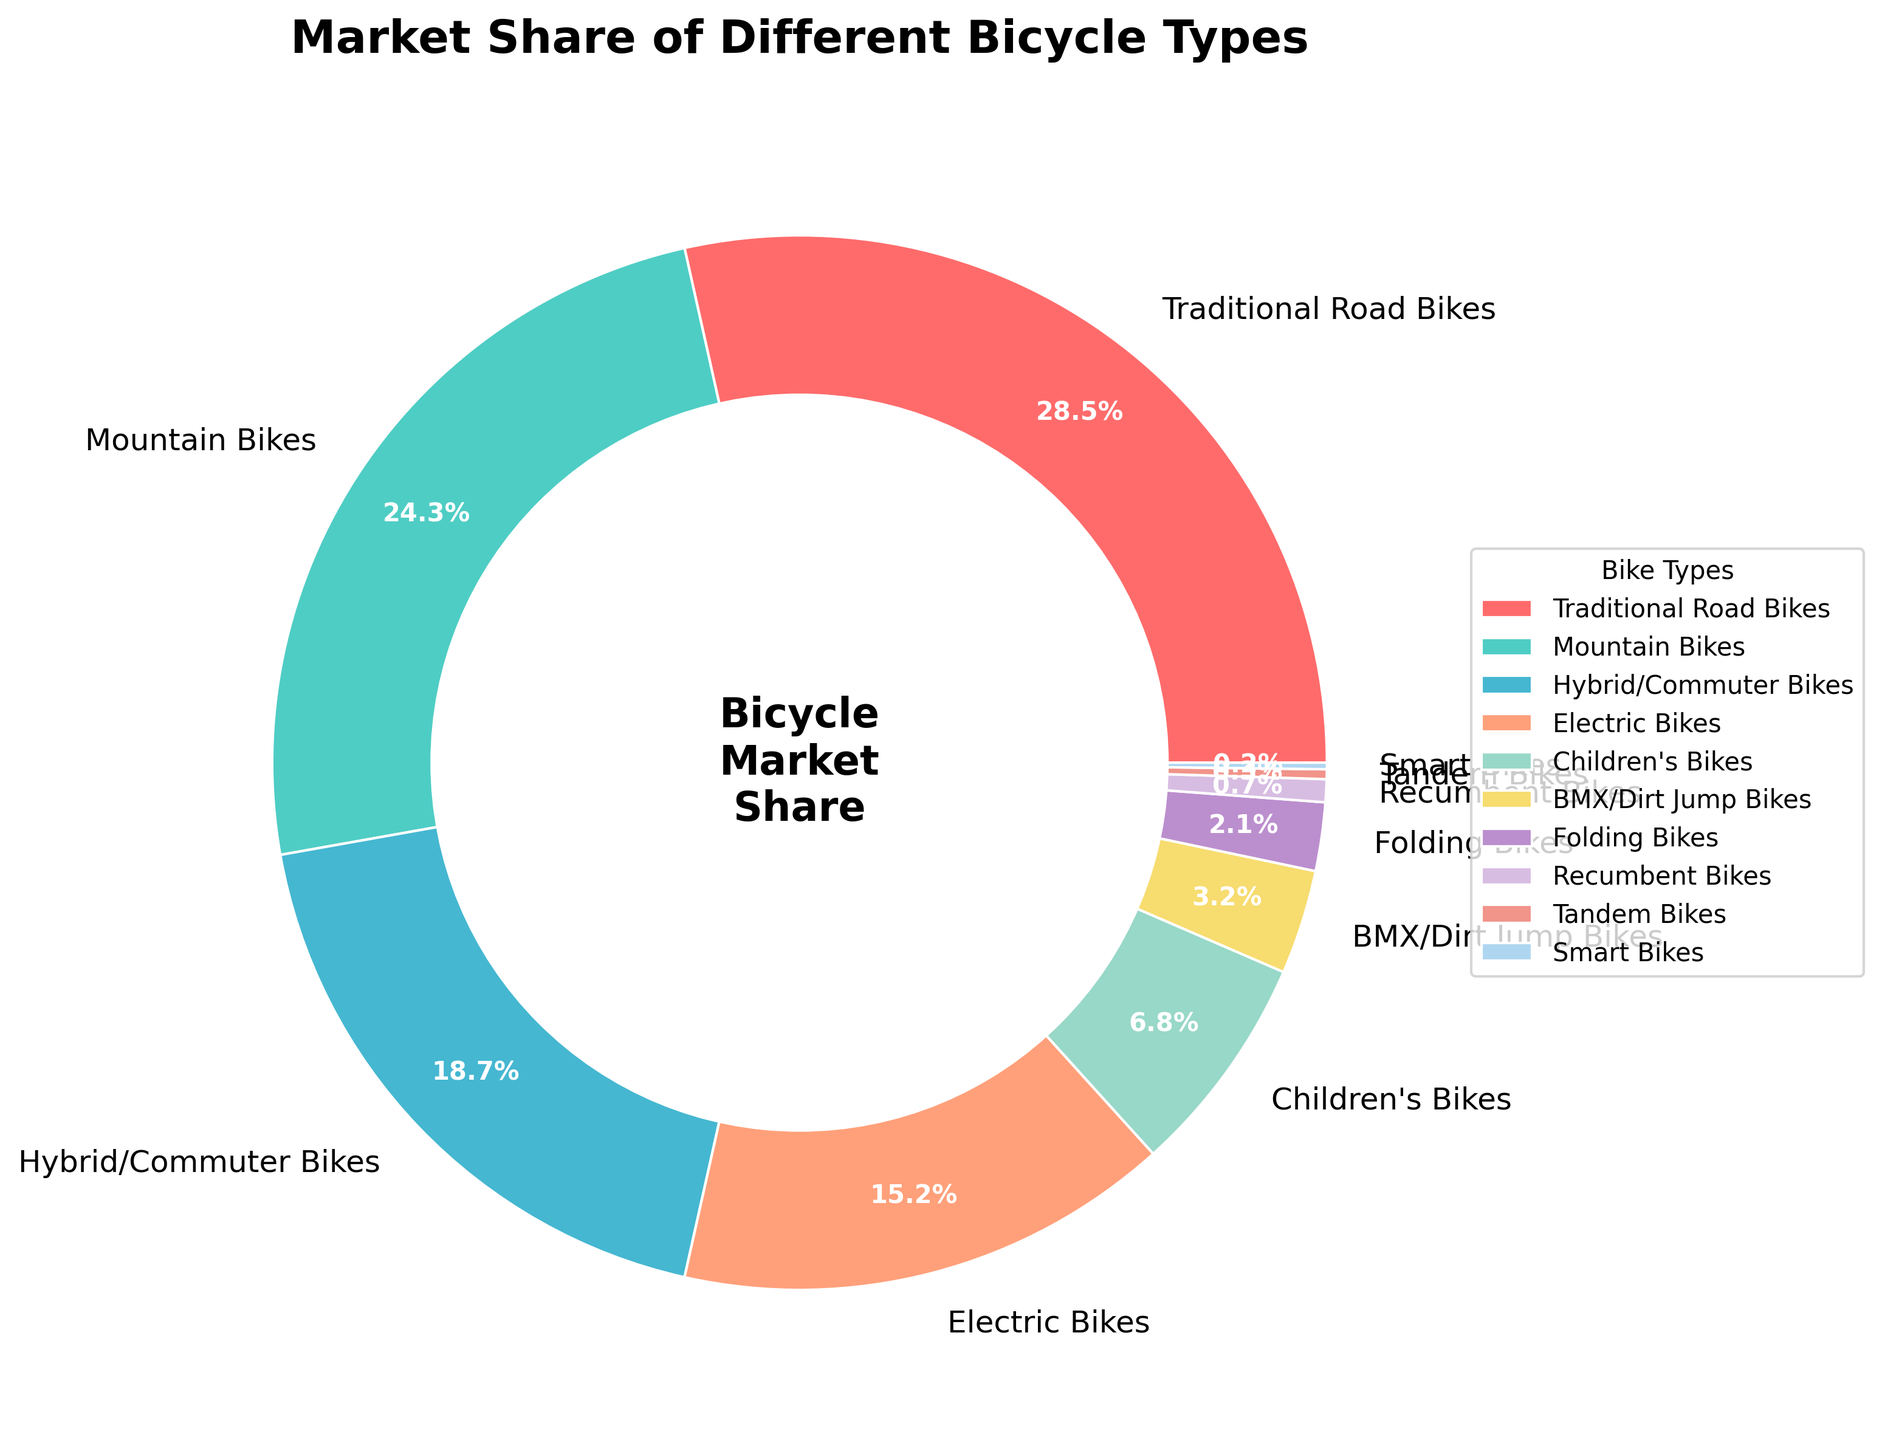What are the two most popular types of bikes and their combined market share? By looking at the wedges of the pie chart, the two largest segments are Traditional Road Bikes (28.5%) and Mountain Bikes (24.3%). Adding these percentages together gives 28.5 + 24.3 = 52.8%.
Answer: Traditional Road Bikes and Mountain Bikes, 52.8% Which bike type has a market share closest to 20%? We need to identify the segment whose percentage is nearest to 20%. Hybrid/Commuter Bikes have a market share of 18.7%, which is the closest to 20%.
Answer: Hybrid/Commuter Bikes Is the market share of Electric Bikes greater than the combined market share of Children's Bikes and BMX/Dirt Jump Bikes? Electric Bikes have a market share of 15.2%. Combined market share of Children's Bikes (6.8%) and BMX/Dirt Jump Bikes (3.2%) is 6.8 + 3.2 = 10%. Since 15.2% > 10%, Electric Bikes' market share is indeed greater.
Answer: Yes What is the total market share of the least popular three bike types? The least popular three types are Smart Bikes (0.2%), Tandem Bikes (0.3%), and Recumbent Bikes (0.7%). Adding their market shares gives 0.2 + 0.3 + 0.7 = 1.2%.
Answer: 1.2% How does the market share of Folding Bikes compare to that of Children's Bikes? By comparing the two wedges, Folding Bikes have a market share of 2.1%, while Children's Bikes have a 6.8% share. Thus, the market share of Folding Bikes is less than that of Children's Bikes.
Answer: Less Which segment is represented by the red color in the pie chart? By referring to the description of colors used, the red color is assigned to the Traditional Road Bikes, which has the largest segment on the pie chart.
Answer: Traditional Road Bikes If you combine the market shares of Hybrid/Commuter Bikes and Electric Bikes, do they surpass the market share of Mountain Bikes? Hybrid/Commuter Bikes have 18.7% and Electric Bikes have 15.2%. Their combined market share is 18.7 + 15.2 = 33.9%. The market share of Mountain Bikes is 24.3%, so 33.9% > 24.3%.
Answer: Yes Which bike type has the smallest market share, and what is its value? By examining the smallest wedge, Smart Bikes have the smallest market share at 0.2%.
Answer: Smart Bikes, 0.2% Is the market share of Traditional Road Bikes more than double that of Hybrid/Commuter Bikes? Traditional Road Bikes have a share of 28.5%, and Hybrid/Commuter Bikes have 18.7%. Doubling Hybrid/Commuter Bikes' share gives 18.7 * 2 = 37.4%, which is more than 28.5%, so it's not more than double.
Answer: No What is the approximate difference in market share between the most popular and the least popular bike types? The most popular bike type is Traditional Road Bikes at 28.5%, and the least popular is Smart Bikes at 0.2%. The difference is 28.5 - 0.2 = 28.3%.
Answer: 28.3% 